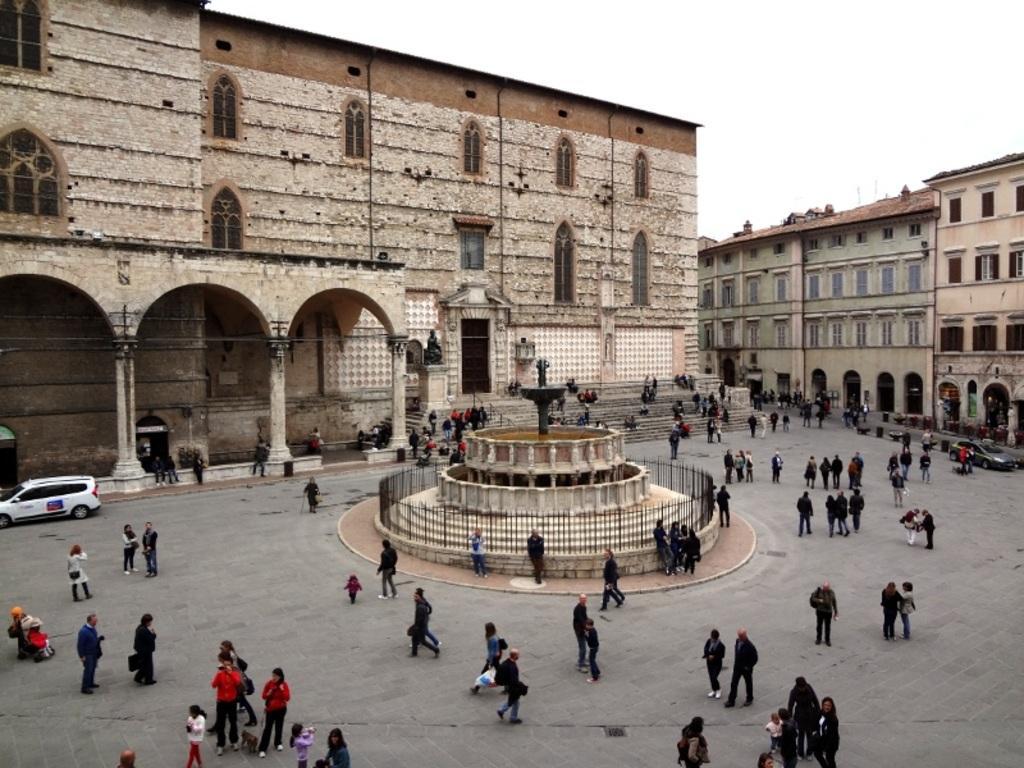Describe this image in one or two sentences. In this image I see the buildings, path on which there are number of people and I see the cars, pillars and a sculpture over here. In the background I see the clear sky and I can also see the steps over here. 